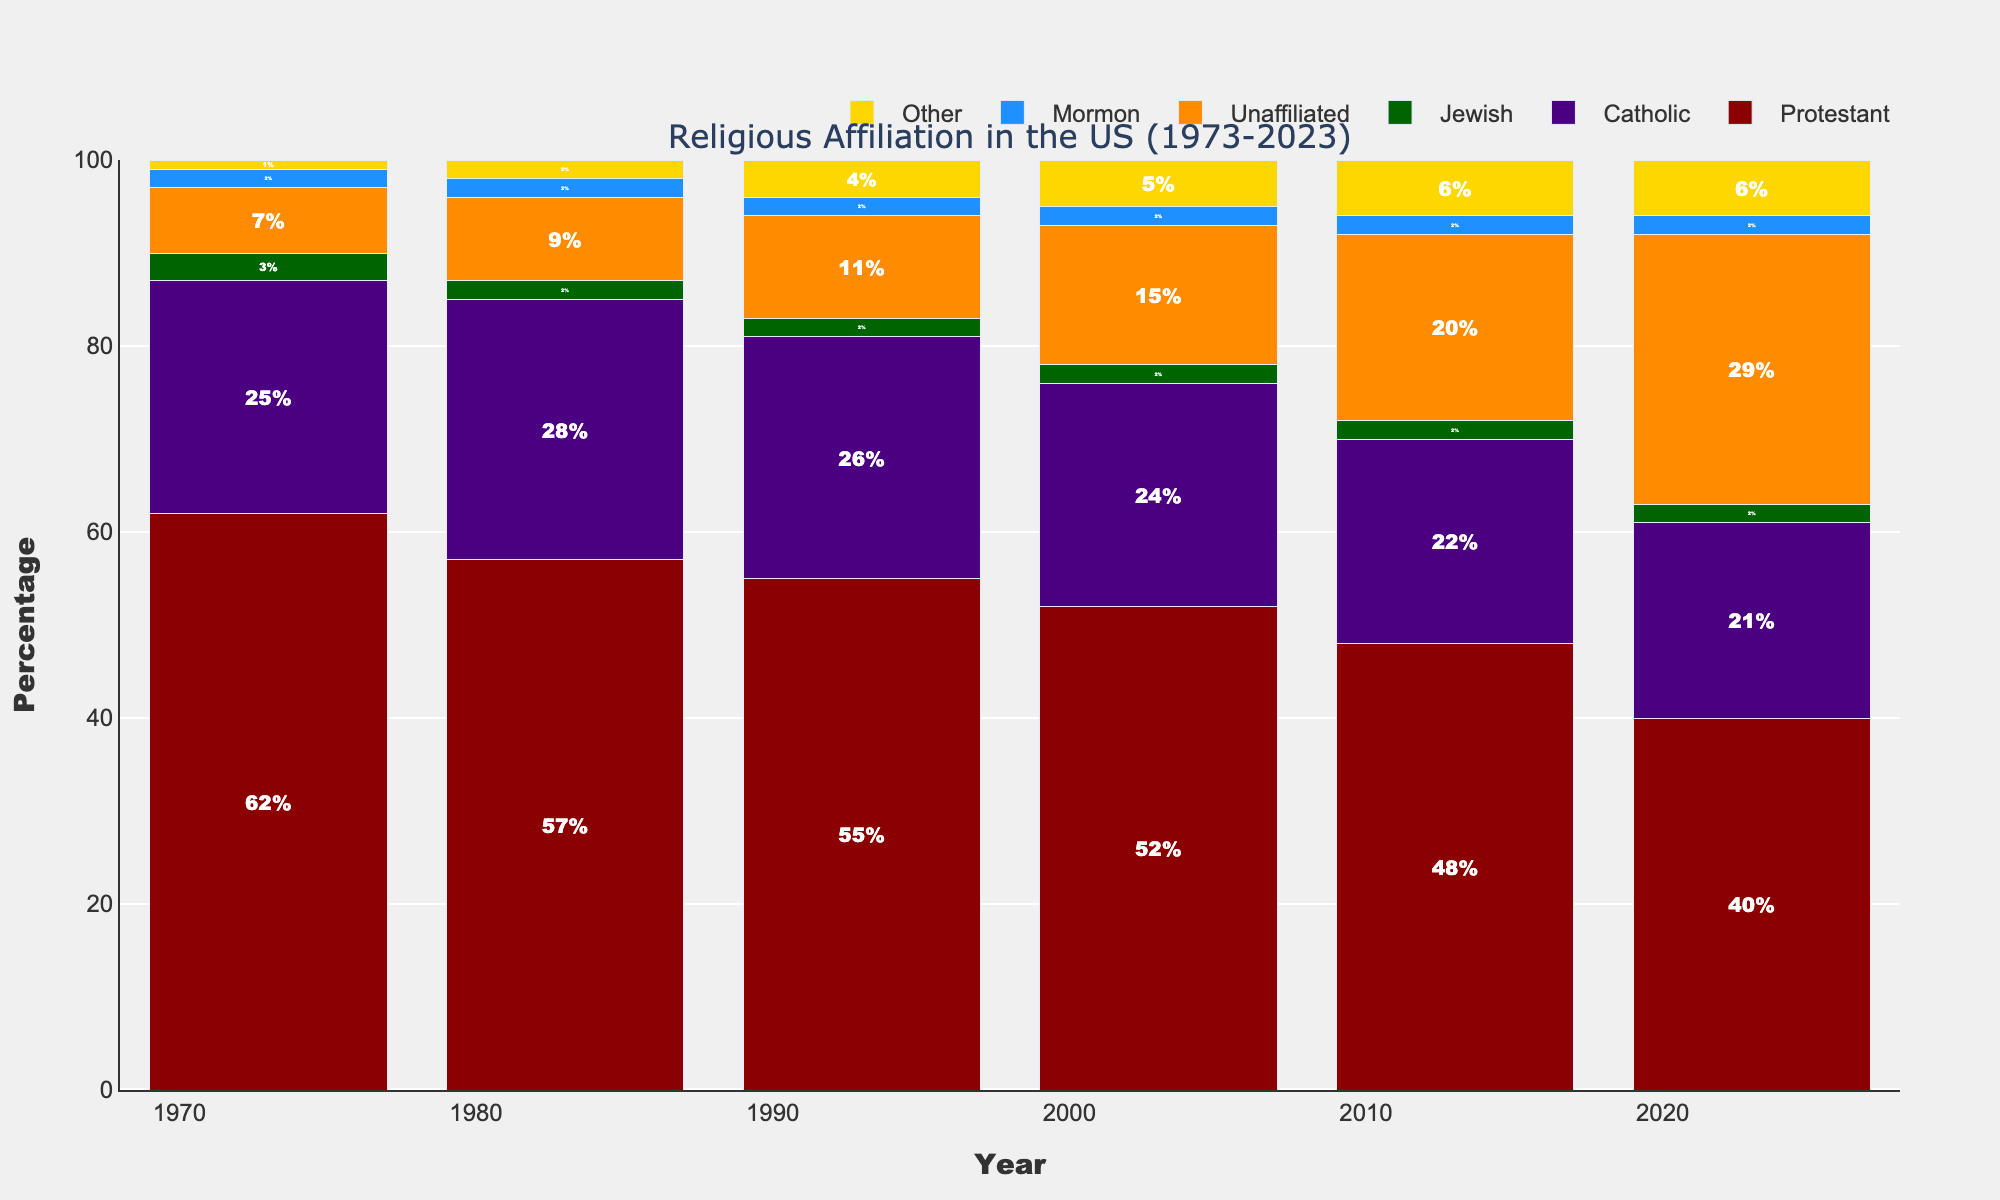which group has the highest percentage in 2023? Look at the bar chart for the year 2023. The tallest bar represents the group with the highest percentage, which is "Unaffiliated."
Answer: Unaffiliated what is the difference in Protestant affiliation between 1973 and 2023? To find the difference, look at the percentage of Protestant affiliation in 1973 and 2023. Subtract the 2023 value (40%) from the 1973 value (62%).
Answer: 22% which religious group has remained the most stable over the years? Each group's stability can be determined by the visual change in bar height over the years. The "Jewish" group shows the least change in height, remaining constant at 2-3% throughout.
Answer: Jewish how many groups had an increase in their percentage from 1973 to 2023? Check the value for each group in 1973 and compare it to 2023. The groups with increases are "Catholic" (increase), "Unaffiliated" (increase), "Mormon" (stable), and "Other" (increase). Count these groups.
Answer: 3 which two groups are closest in affiliation percentage in 1983? Examine the bars for the year 1983 and compare their heights. "Jewish" and "Mormon" both have percentages close to 2%.
Answer: Jewish and Mormon what is the sum of percentages for Protestant, Catholic, and Unaffiliated affiliation in 2023? Add the percentages of these three groups in 2023. Protestant: 40%, Catholic: 21%, Unaffiliated: 29%. So, 40 + 21 + 29 = 90.
Answer: 90% how has the percentage of unaffiliated people changed from 1973 to 2023? To find the change, subtract the 1973 percentage (7%) from the 2023 percentage (29%). This tells how much the percentage has increased.
Answer: 22% which group decreased the most in percentage from 1973 to 2023? Compare the values from 1973 and 2023 for each group. The "Protestant" group decreased the most, going from 62% to 40%.
Answer: Protestant how does the percentage of the "Other" group in 2023 compare to the "Jewish" group in the same year? Look at the bars for the "Other" and "Jewish" groups in 2023. The "Other" group has 6%, while the "Jewish" group has 2%. The "Other" group has a higher percentage.
Answer: Other is higher 